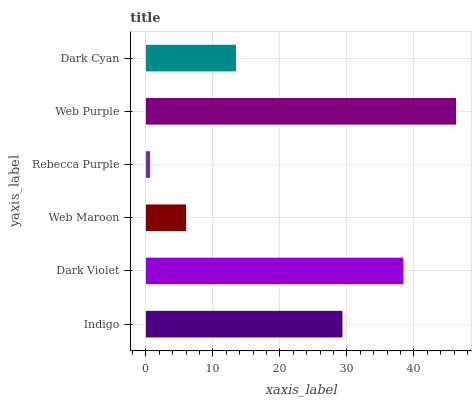Is Rebecca Purple the minimum?
Answer yes or no. Yes. Is Web Purple the maximum?
Answer yes or no. Yes. Is Dark Violet the minimum?
Answer yes or no. No. Is Dark Violet the maximum?
Answer yes or no. No. Is Dark Violet greater than Indigo?
Answer yes or no. Yes. Is Indigo less than Dark Violet?
Answer yes or no. Yes. Is Indigo greater than Dark Violet?
Answer yes or no. No. Is Dark Violet less than Indigo?
Answer yes or no. No. Is Indigo the high median?
Answer yes or no. Yes. Is Dark Cyan the low median?
Answer yes or no. Yes. Is Rebecca Purple the high median?
Answer yes or no. No. Is Rebecca Purple the low median?
Answer yes or no. No. 